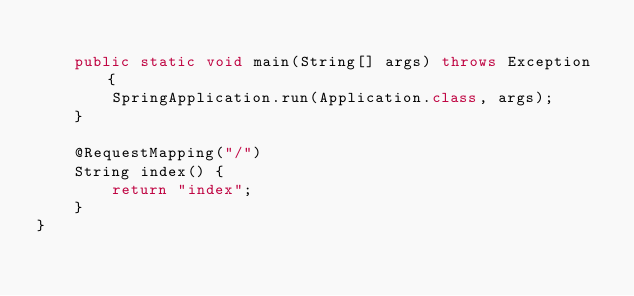<code> <loc_0><loc_0><loc_500><loc_500><_Java_>
    public static void main(String[] args) throws Exception {
        SpringApplication.run(Application.class, args);
    }

    @RequestMapping("/")
    String index() {
        return "index";
    }
}
</code> 